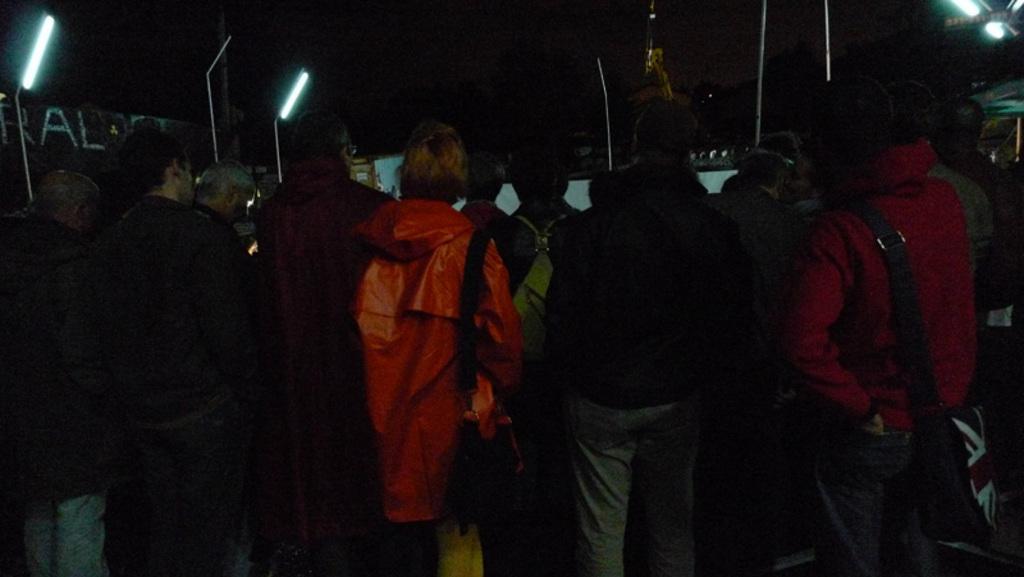How would you summarize this image in a sentence or two? In this image we can see people standing and there are poles. We can see lights and sheds. 